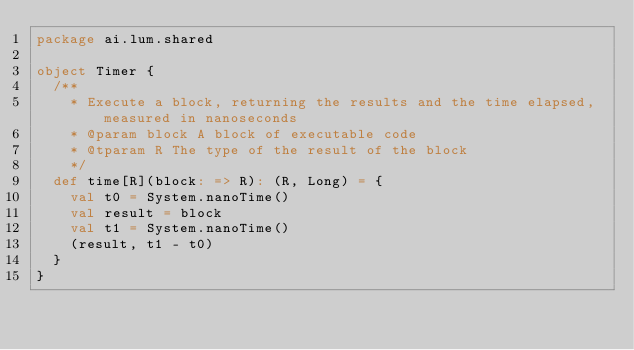Convert code to text. <code><loc_0><loc_0><loc_500><loc_500><_Scala_>package ai.lum.shared

object Timer {
  /**
    * Execute a block, returning the results and the time elapsed, measured in nanoseconds
    * @param block A block of executable code
    * @tparam R The type of the result of the block
    */
  def time[R](block: => R): (R, Long) = {
    val t0 = System.nanoTime()
    val result = block
    val t1 = System.nanoTime()
    (result, t1 - t0)
  }
}
</code> 